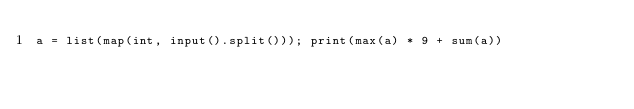Convert code to text. <code><loc_0><loc_0><loc_500><loc_500><_Python_>a = list(map(int, input().split())); print(max(a) * 9 + sum(a))</code> 